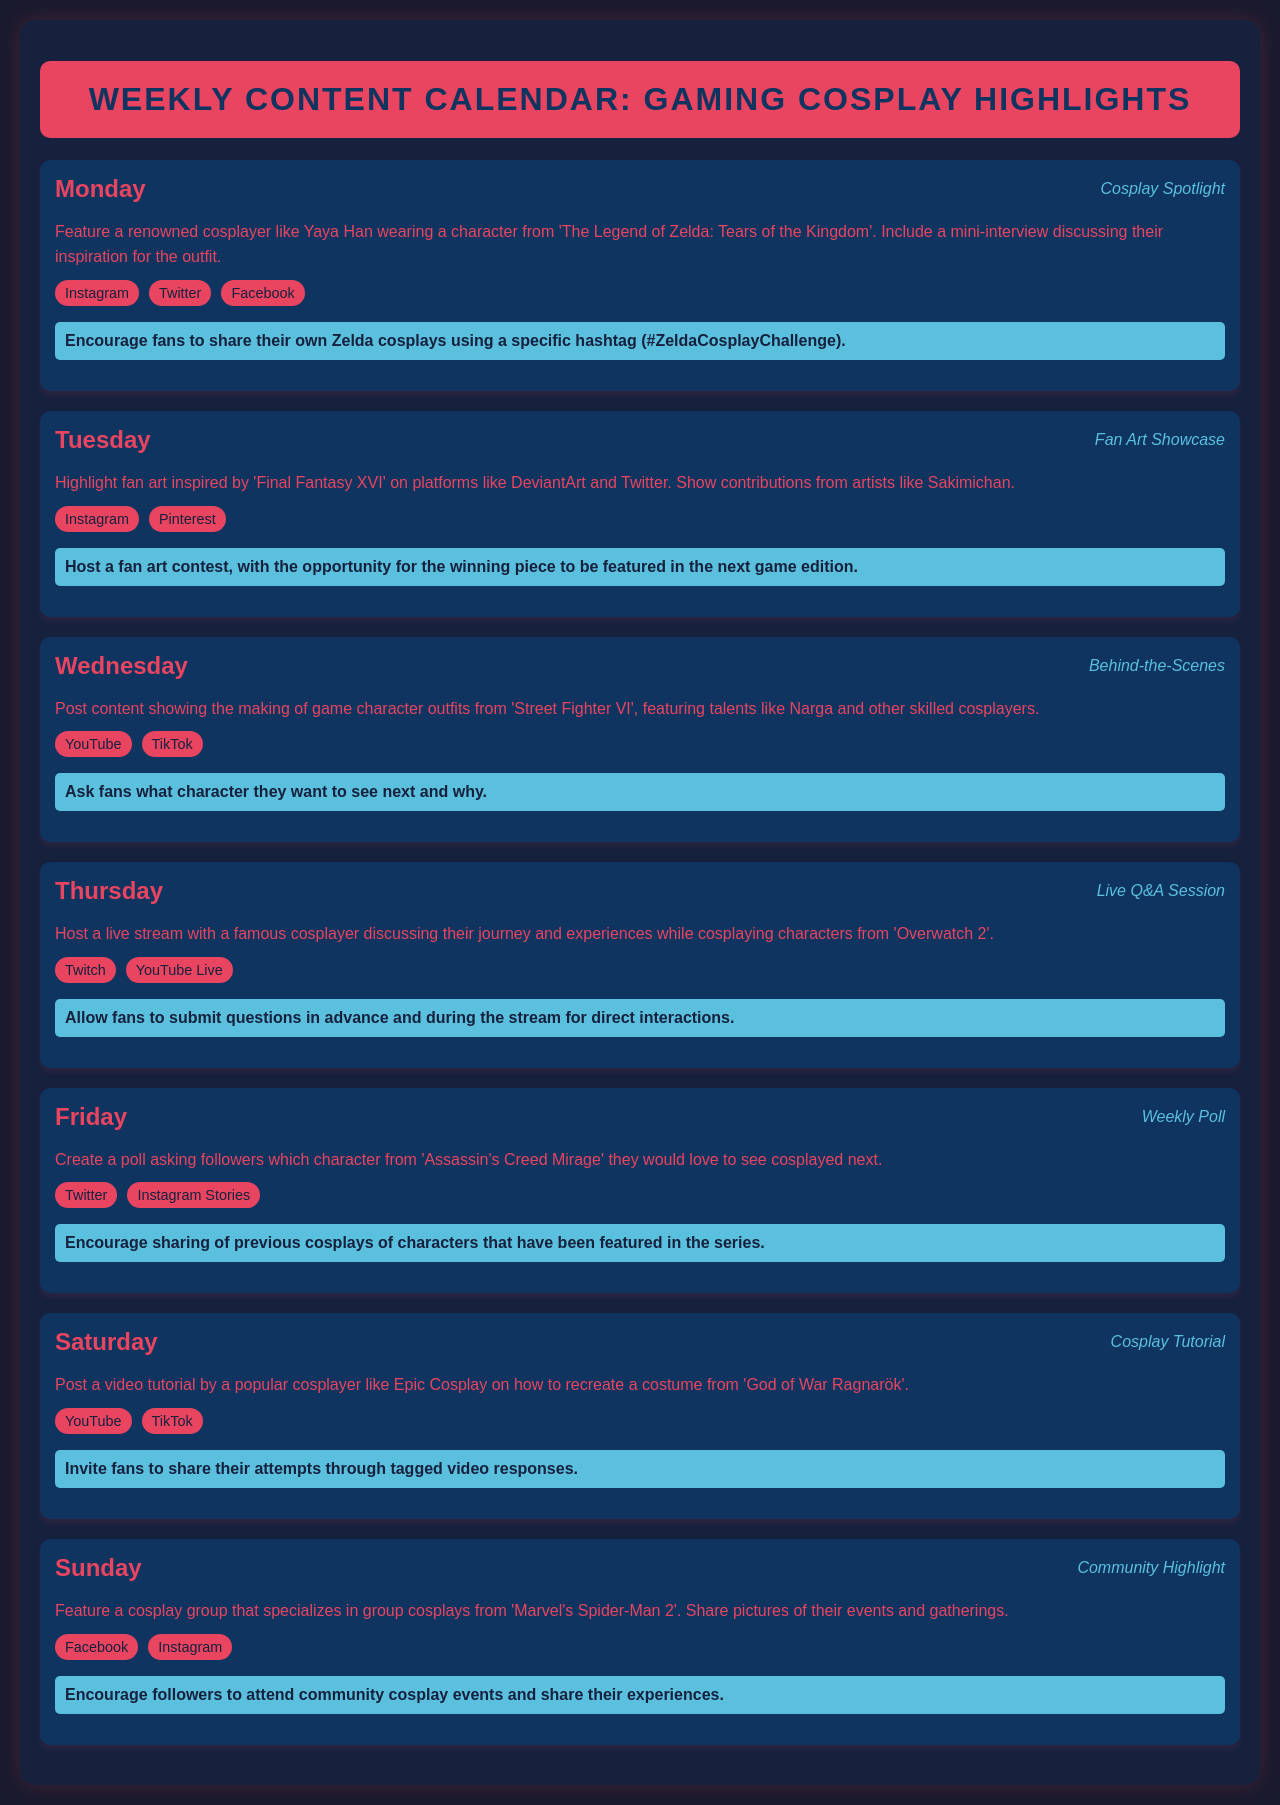What cosplay character will be featured on Monday? The schedule states that the cosplay spotlight for Monday features a character from 'The Legend of Zelda: Tears of the Kingdom'.
Answer: Zelda Who is the renowned cosplayer featured on Monday? The document mentions Yaya Han as the renowned cosplayer featured in the Monday's cosplay spotlight.
Answer: Yaya Han What type of content is highlighted on Tuesday? The Tuesday entry describes a showcase of fan art inspired by a specific game.
Answer: Fan Art Showcase Which platform will host the live Q&A session on Thursday? The schedule lists Twitch and YouTube Live as the platforms for the live Q&A session on Thursday.
Answer: Twitch What engagement activity is suggested for Friday? The document states that followers are encouraged to participate in a poll regarding character cosplays from a game.
Answer: Weekly Poll How many platforms are mentioned for Saturday's content type? The Saturday entry lists two platforms where the cosplay tutorial will be posted.
Answer: Two What type of content will be posted on Sunday? The content featured on Sunday is a community highlight focusing on a specific cosplay group.
Answer: Community Highlight What game is associated with the cosplay tutorial on Saturday? The schedule specifies that the tutorial relates to a costume from 'God of War Ragnarök'.
Answer: God of War Ragnarök What incentive is offered to the winner of the fan art contest mentioned on Tuesday? The document mentions that the winning piece will be featured in the next game edition as an incentive.
Answer: Featured in the next game edition 